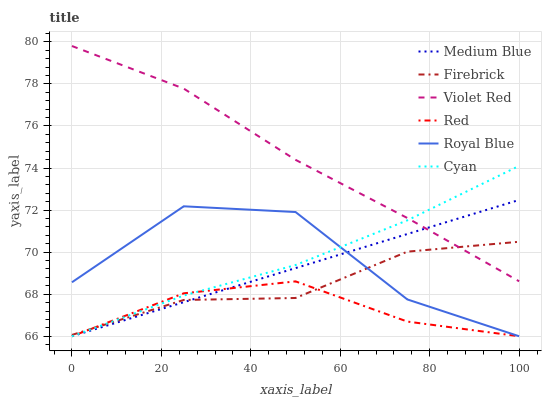Does Red have the minimum area under the curve?
Answer yes or no. Yes. Does Violet Red have the maximum area under the curve?
Answer yes or no. Yes. Does Firebrick have the minimum area under the curve?
Answer yes or no. No. Does Firebrick have the maximum area under the curve?
Answer yes or no. No. Is Medium Blue the smoothest?
Answer yes or no. Yes. Is Royal Blue the roughest?
Answer yes or no. Yes. Is Firebrick the smoothest?
Answer yes or no. No. Is Firebrick the roughest?
Answer yes or no. No. Does Firebrick have the lowest value?
Answer yes or no. No. Does Violet Red have the highest value?
Answer yes or no. Yes. Does Firebrick have the highest value?
Answer yes or no. No. Is Royal Blue less than Violet Red?
Answer yes or no. Yes. Is Violet Red greater than Red?
Answer yes or no. Yes. Does Royal Blue intersect Violet Red?
Answer yes or no. No. 